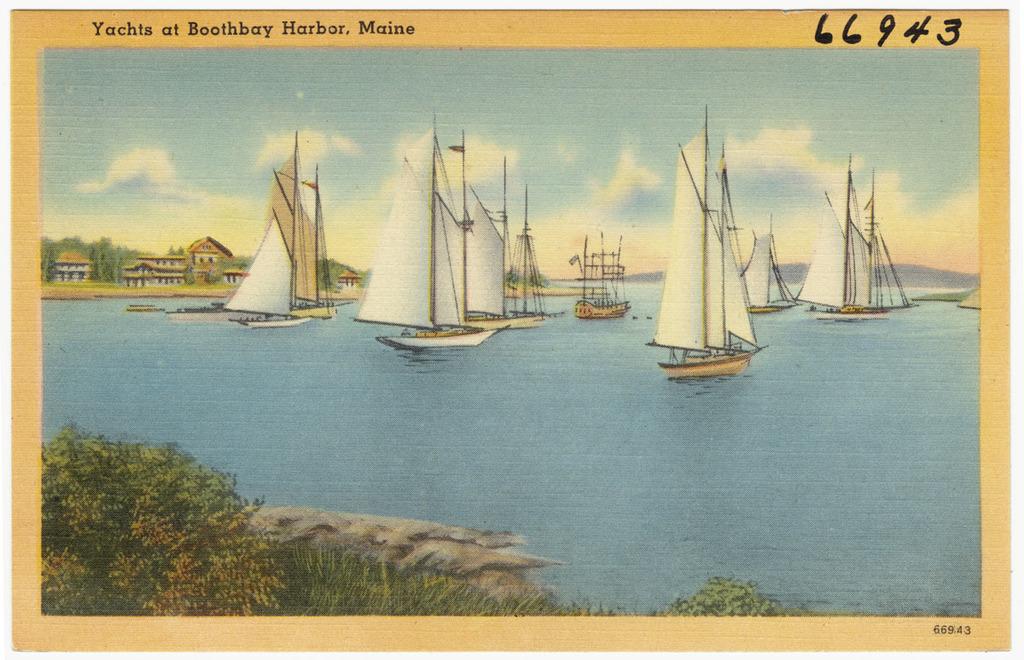What is the identification markings on the piece?
Give a very brief answer. 66943. What state is the picture based upon?
Your answer should be very brief. Maine. 